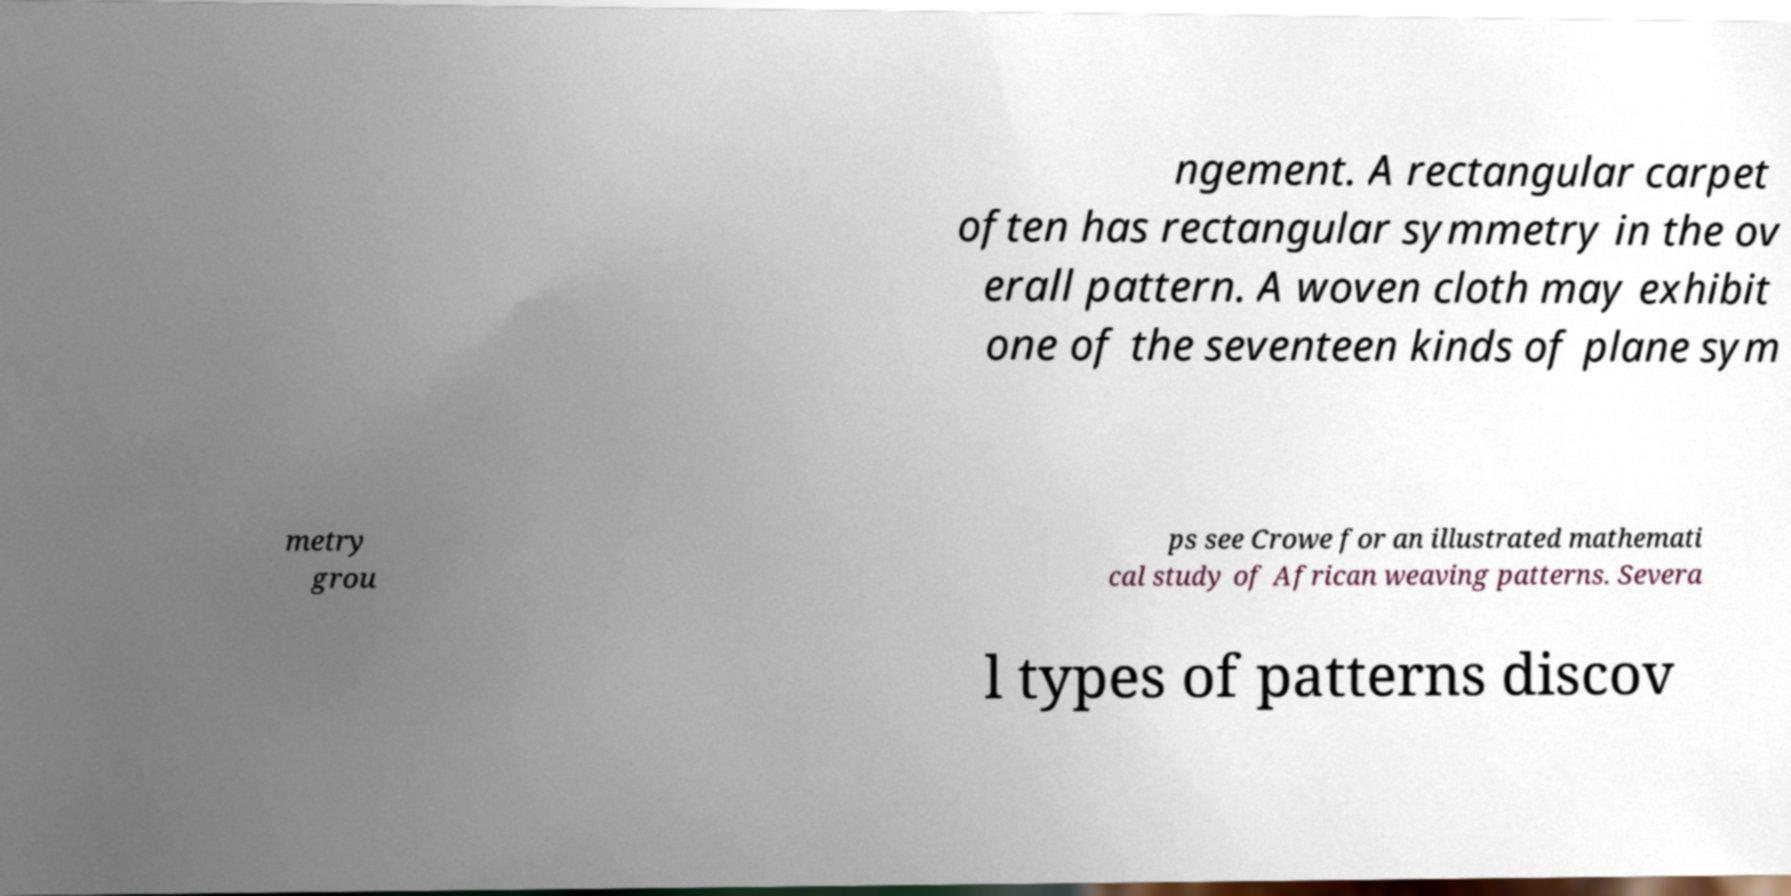Can you read and provide the text displayed in the image?This photo seems to have some interesting text. Can you extract and type it out for me? ngement. A rectangular carpet often has rectangular symmetry in the ov erall pattern. A woven cloth may exhibit one of the seventeen kinds of plane sym metry grou ps see Crowe for an illustrated mathemati cal study of African weaving patterns. Severa l types of patterns discov 